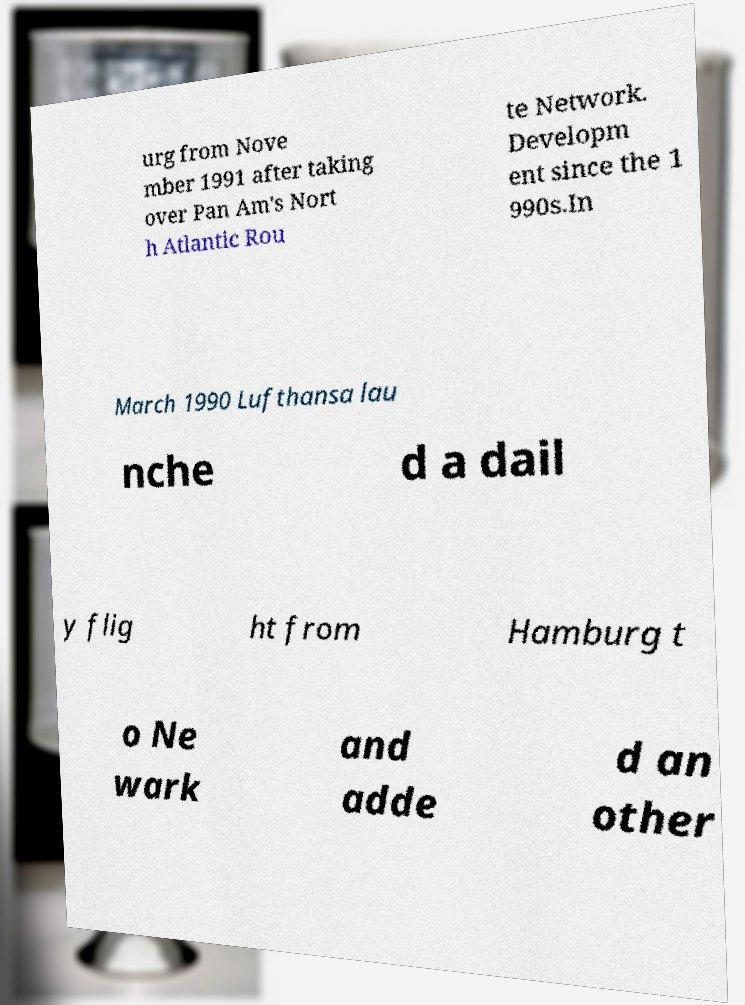What messages or text are displayed in this image? I need them in a readable, typed format. urg from Nove mber 1991 after taking over Pan Am's Nort h Atlantic Rou te Network. Developm ent since the 1 990s.In March 1990 Lufthansa lau nche d a dail y flig ht from Hamburg t o Ne wark and adde d an other 